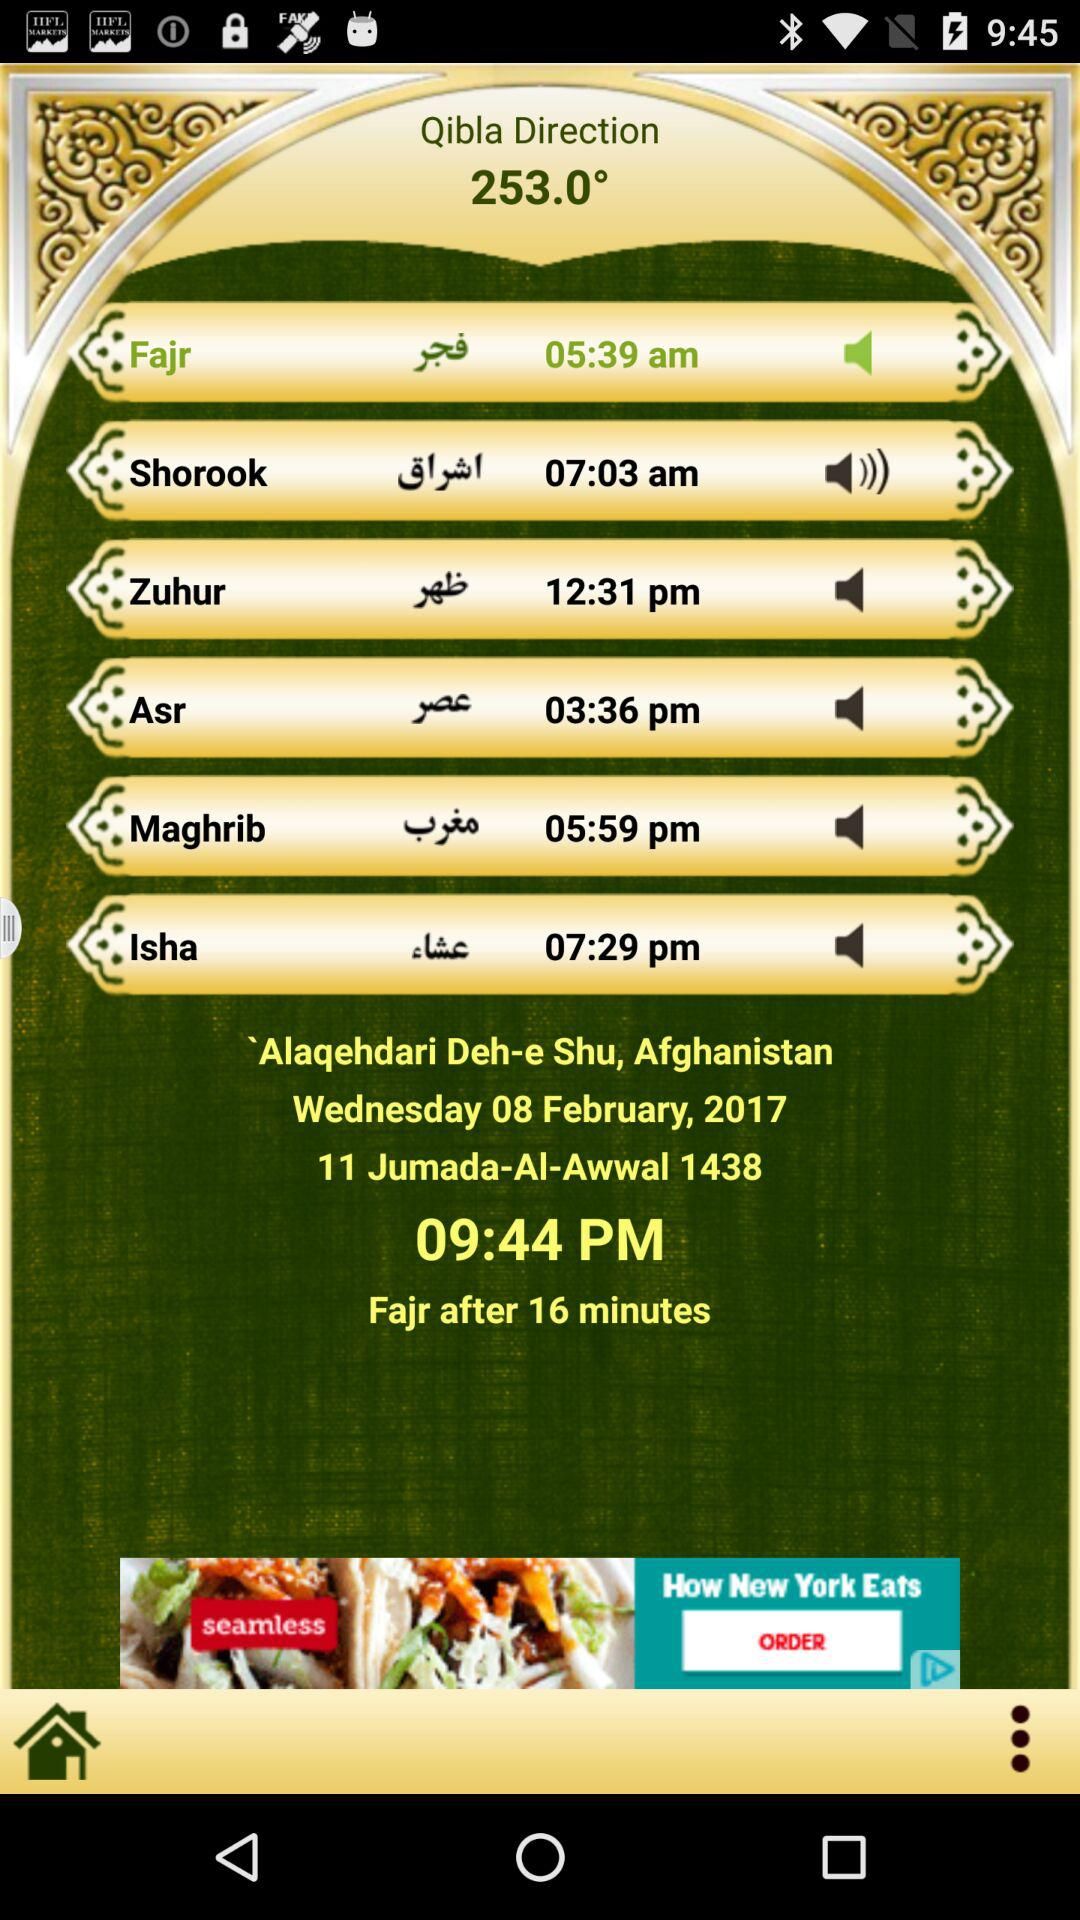What's the time of the event "11 Jumada-Al-Awwal 1438"? The time of the event is 09:44 PM. 